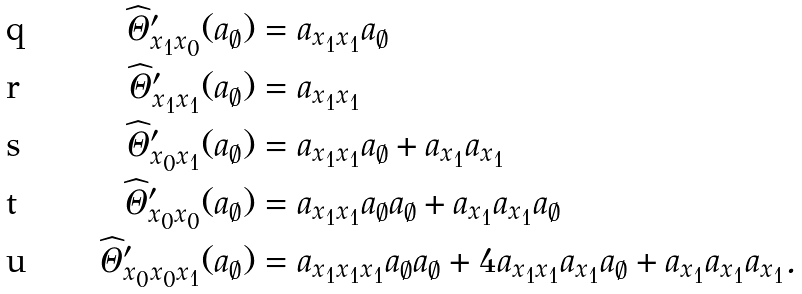Convert formula to latex. <formula><loc_0><loc_0><loc_500><loc_500>\widehat { \Theta } ^ { \prime } _ { x _ { 1 } x _ { 0 } } ( a _ { \emptyset } ) & = a _ { x _ { 1 } x _ { 1 } } a _ { \emptyset } \\ \widehat { \Theta } ^ { \prime } _ { x _ { 1 } x _ { 1 } } ( a _ { \emptyset } ) & = a _ { x _ { 1 } x _ { 1 } } \\ \widehat { \Theta } ^ { \prime } _ { x _ { 0 } x _ { 1 } } ( a _ { \emptyset } ) & = a _ { x _ { 1 } x _ { 1 } } a _ { \emptyset } + a _ { x _ { 1 } } a _ { x _ { 1 } } \\ \widehat { \Theta } ^ { \prime } _ { x _ { 0 } x _ { 0 } } ( a _ { \emptyset } ) & = a _ { x _ { 1 } x _ { 1 } } a _ { \emptyset } a _ { \emptyset } + a _ { x _ { 1 } } a _ { x _ { 1 } } a _ { \emptyset } \\ \widehat { \Theta } ^ { \prime } _ { x _ { 0 } x _ { 0 } x _ { 1 } } ( a _ { \emptyset } ) & = a _ { x _ { 1 } x _ { 1 } x _ { 1 } } a _ { \emptyset } a _ { \emptyset } + 4 a _ { x _ { 1 } x _ { 1 } } a _ { x _ { 1 } } a _ { \emptyset } + a _ { x _ { 1 } } a _ { x _ { 1 } } a _ { x _ { 1 } } .</formula> 